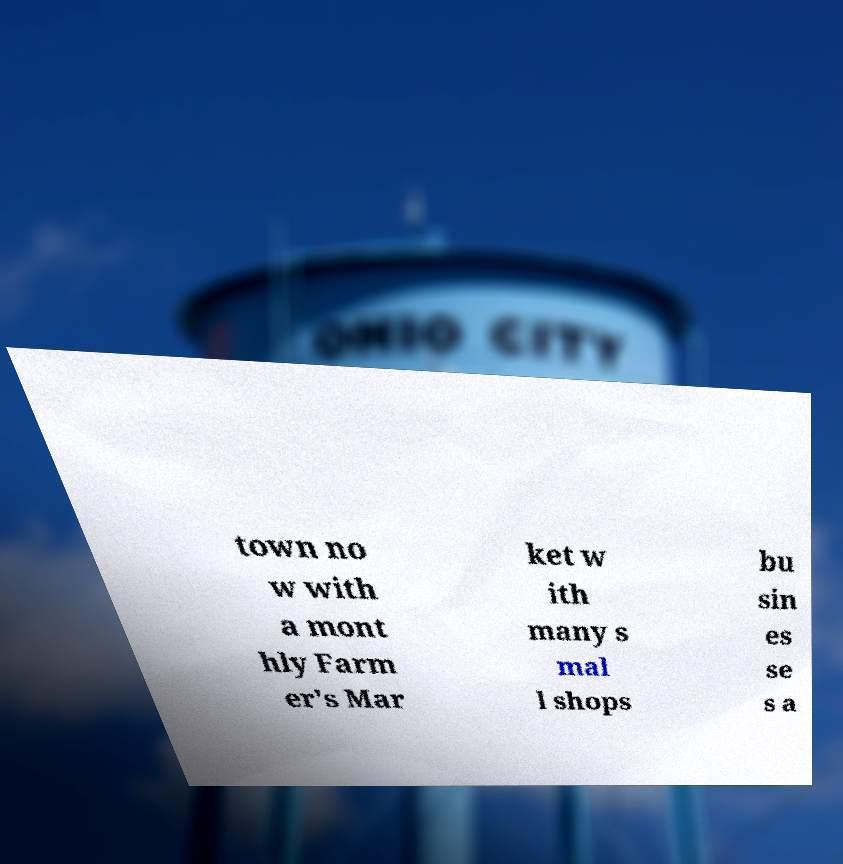Please identify and transcribe the text found in this image. town no w with a mont hly Farm er's Mar ket w ith many s mal l shops bu sin es se s a 